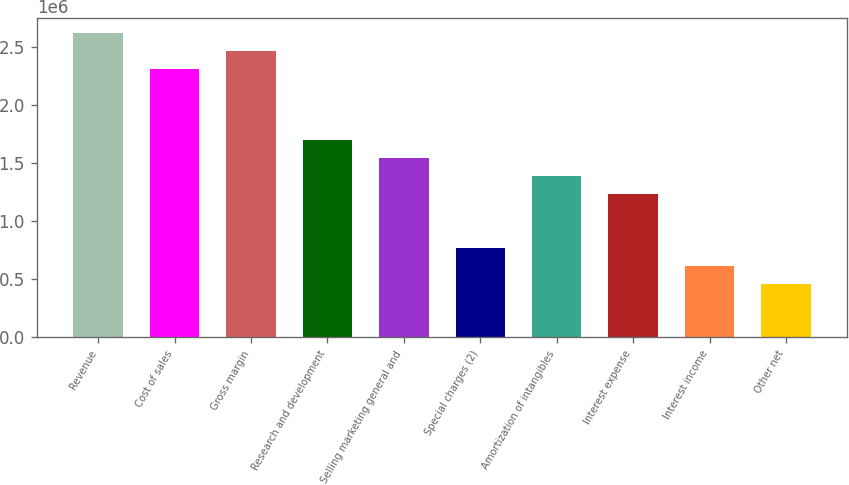<chart> <loc_0><loc_0><loc_500><loc_500><bar_chart><fcel>Revenue<fcel>Cost of sales<fcel>Gross margin<fcel>Research and development<fcel>Selling marketing general and<fcel>Special charges (2)<fcel>Amortization of intangibles<fcel>Interest expense<fcel>Interest income<fcel>Other net<nl><fcel>2.61987e+06<fcel>2.31165e+06<fcel>2.46576e+06<fcel>1.69521e+06<fcel>1.5411e+06<fcel>770551<fcel>1.38699e+06<fcel>1.23288e+06<fcel>616441<fcel>462331<nl></chart> 